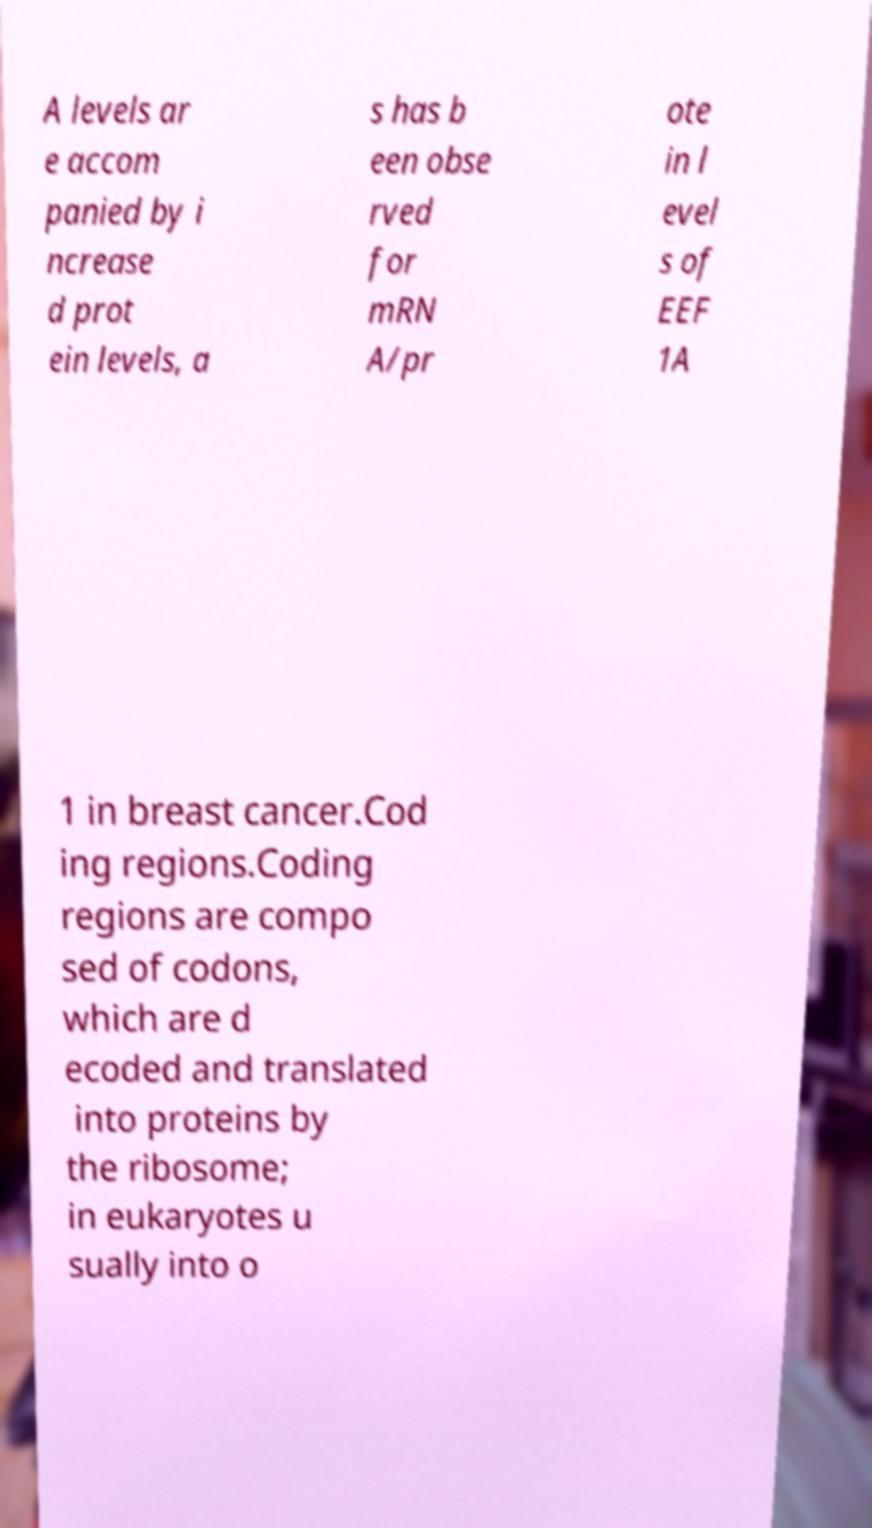What messages or text are displayed in this image? I need them in a readable, typed format. A levels ar e accom panied by i ncrease d prot ein levels, a s has b een obse rved for mRN A/pr ote in l evel s of EEF 1A 1 in breast cancer.Cod ing regions.Coding regions are compo sed of codons, which are d ecoded and translated into proteins by the ribosome; in eukaryotes u sually into o 